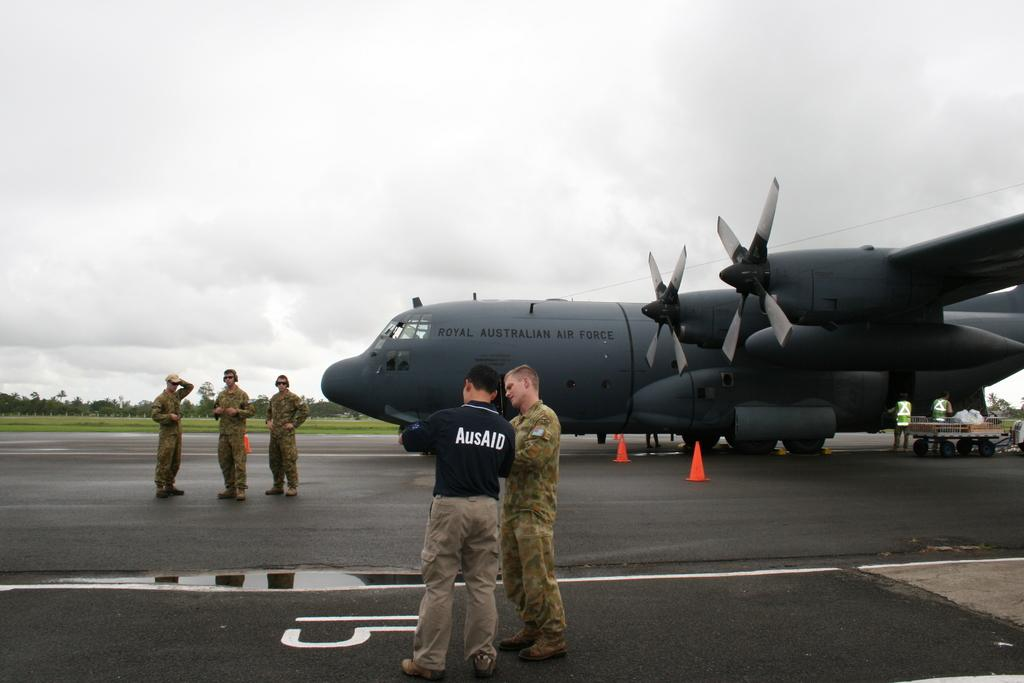<image>
Share a concise interpretation of the image provided. A man in a black AusAid shirt is talking to another man in a military uniform in front of an airplane. 